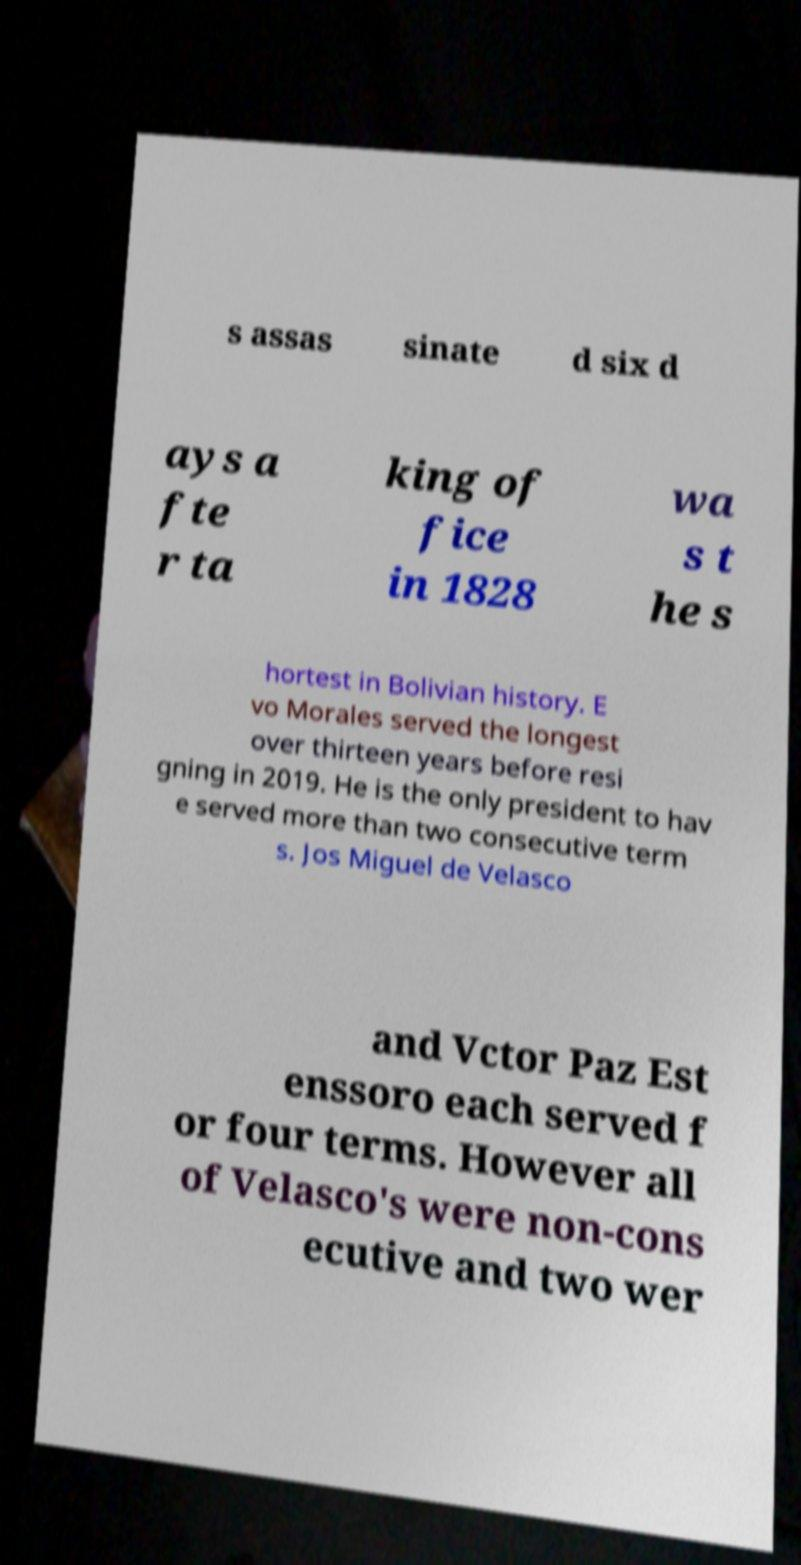Please identify and transcribe the text found in this image. s assas sinate d six d ays a fte r ta king of fice in 1828 wa s t he s hortest in Bolivian history. E vo Morales served the longest over thirteen years before resi gning in 2019. He is the only president to hav e served more than two consecutive term s. Jos Miguel de Velasco and Vctor Paz Est enssoro each served f or four terms. However all of Velasco's were non-cons ecutive and two wer 